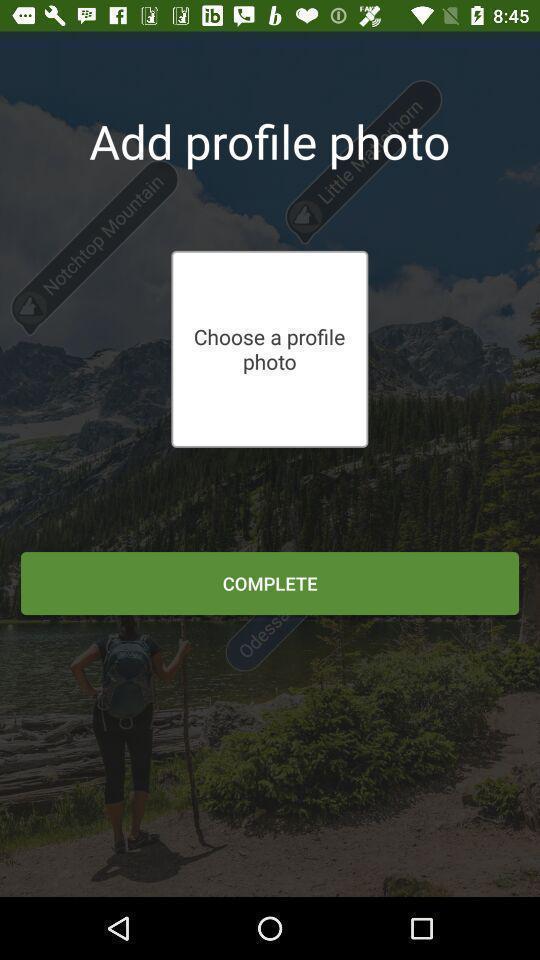Explain the elements present in this screenshot. Screen showing add profile photo. 